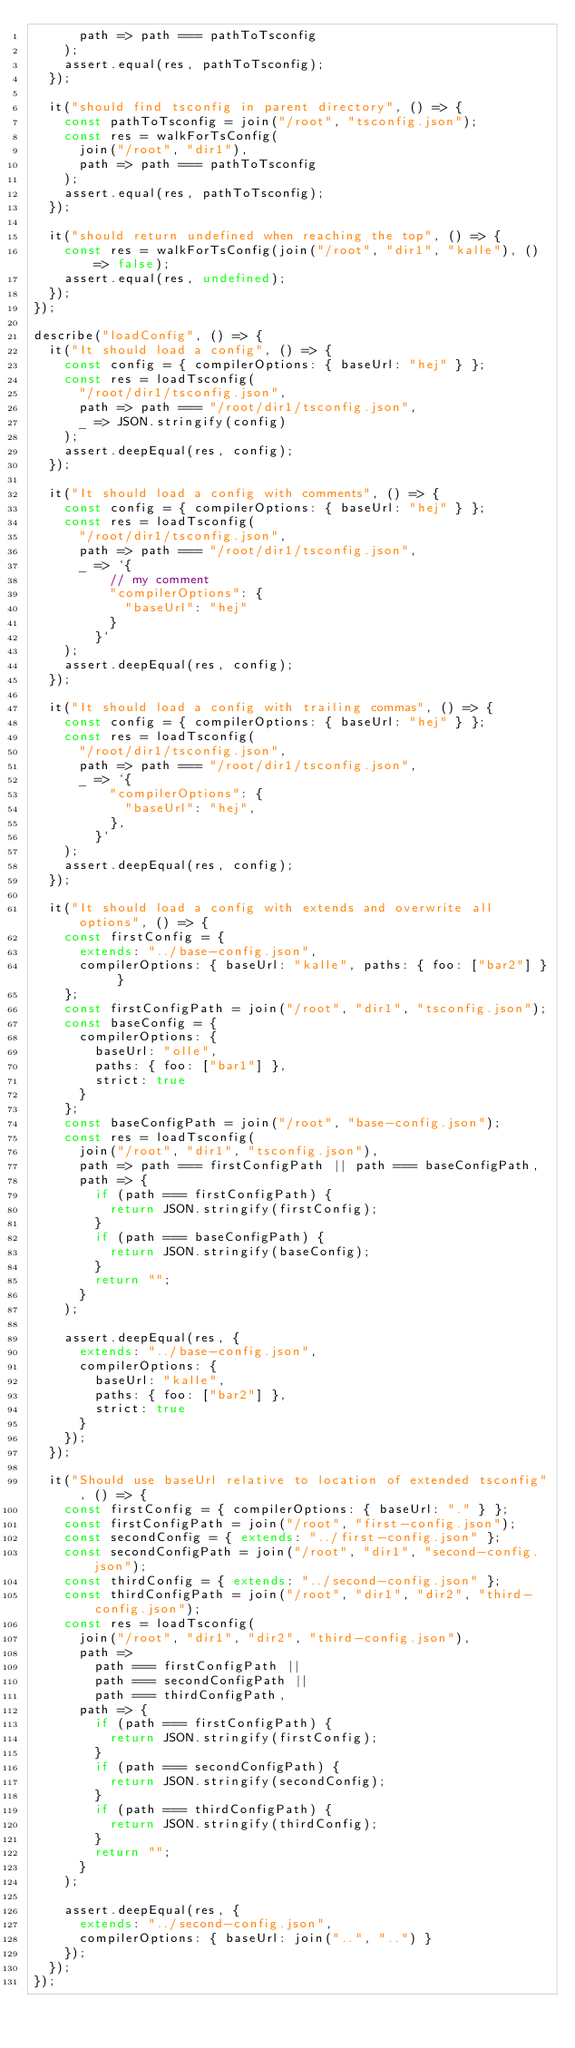<code> <loc_0><loc_0><loc_500><loc_500><_TypeScript_>      path => path === pathToTsconfig
    );
    assert.equal(res, pathToTsconfig);
  });

  it("should find tsconfig in parent directory", () => {
    const pathToTsconfig = join("/root", "tsconfig.json");
    const res = walkForTsConfig(
      join("/root", "dir1"),
      path => path === pathToTsconfig
    );
    assert.equal(res, pathToTsconfig);
  });

  it("should return undefined when reaching the top", () => {
    const res = walkForTsConfig(join("/root", "dir1", "kalle"), () => false);
    assert.equal(res, undefined);
  });
});

describe("loadConfig", () => {
  it("It should load a config", () => {
    const config = { compilerOptions: { baseUrl: "hej" } };
    const res = loadTsconfig(
      "/root/dir1/tsconfig.json",
      path => path === "/root/dir1/tsconfig.json",
      _ => JSON.stringify(config)
    );
    assert.deepEqual(res, config);
  });

  it("It should load a config with comments", () => {
    const config = { compilerOptions: { baseUrl: "hej" } };
    const res = loadTsconfig(
      "/root/dir1/tsconfig.json",
      path => path === "/root/dir1/tsconfig.json",
      _ => `{
          // my comment
          "compilerOptions": { 
            "baseUrl": "hej"
          }
        }`
    );
    assert.deepEqual(res, config);
  });

  it("It should load a config with trailing commas", () => {
    const config = { compilerOptions: { baseUrl: "hej" } };
    const res = loadTsconfig(
      "/root/dir1/tsconfig.json",
      path => path === "/root/dir1/tsconfig.json",
      _ => `{
          "compilerOptions": { 
            "baseUrl": "hej",
          },
        }`
    );
    assert.deepEqual(res, config);
  });

  it("It should load a config with extends and overwrite all options", () => {
    const firstConfig = {
      extends: "../base-config.json",
      compilerOptions: { baseUrl: "kalle", paths: { foo: ["bar2"] } }
    };
    const firstConfigPath = join("/root", "dir1", "tsconfig.json");
    const baseConfig = {
      compilerOptions: {
        baseUrl: "olle",
        paths: { foo: ["bar1"] },
        strict: true
      }
    };
    const baseConfigPath = join("/root", "base-config.json");
    const res = loadTsconfig(
      join("/root", "dir1", "tsconfig.json"),
      path => path === firstConfigPath || path === baseConfigPath,
      path => {
        if (path === firstConfigPath) {
          return JSON.stringify(firstConfig);
        }
        if (path === baseConfigPath) {
          return JSON.stringify(baseConfig);
        }
        return "";
      }
    );

    assert.deepEqual(res, {
      extends: "../base-config.json",
      compilerOptions: {
        baseUrl: "kalle",
        paths: { foo: ["bar2"] },
        strict: true
      }
    });
  });

  it("Should use baseUrl relative to location of extended tsconfig", () => {
    const firstConfig = { compilerOptions: { baseUrl: "." } };
    const firstConfigPath = join("/root", "first-config.json");
    const secondConfig = { extends: "../first-config.json" };
    const secondConfigPath = join("/root", "dir1", "second-config.json");
    const thirdConfig = { extends: "../second-config.json" };
    const thirdConfigPath = join("/root", "dir1", "dir2", "third-config.json");
    const res = loadTsconfig(
      join("/root", "dir1", "dir2", "third-config.json"),
      path =>
        path === firstConfigPath ||
        path === secondConfigPath ||
        path === thirdConfigPath,
      path => {
        if (path === firstConfigPath) {
          return JSON.stringify(firstConfig);
        }
        if (path === secondConfigPath) {
          return JSON.stringify(secondConfig);
        }
        if (path === thirdConfigPath) {
          return JSON.stringify(thirdConfig);
        }
        return "";
      }
    );

    assert.deepEqual(res, {
      extends: "../second-config.json",
      compilerOptions: { baseUrl: join("..", "..") }
    });
  });
});
</code> 